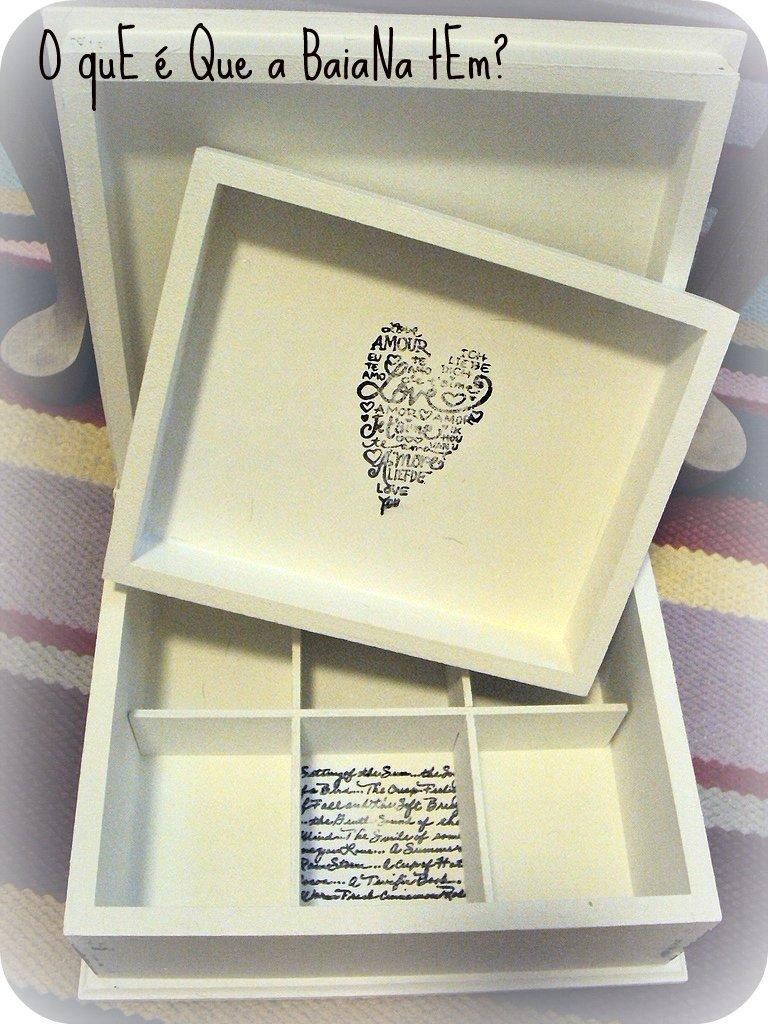<image>
Relay a brief, clear account of the picture shown. A box with a heart on it made up of the word love and similar words 